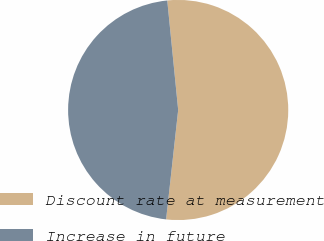Convert chart to OTSL. <chart><loc_0><loc_0><loc_500><loc_500><pie_chart><fcel>Discount rate at measurement<fcel>Increase in future<nl><fcel>53.33%<fcel>46.67%<nl></chart> 